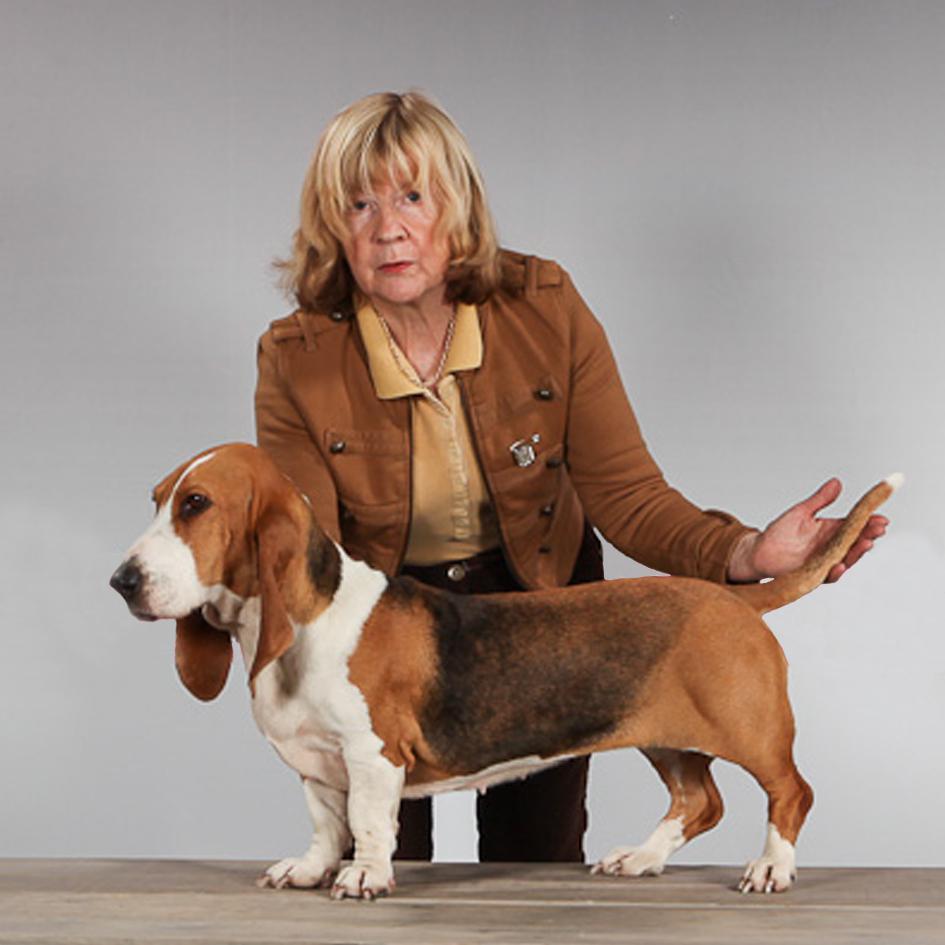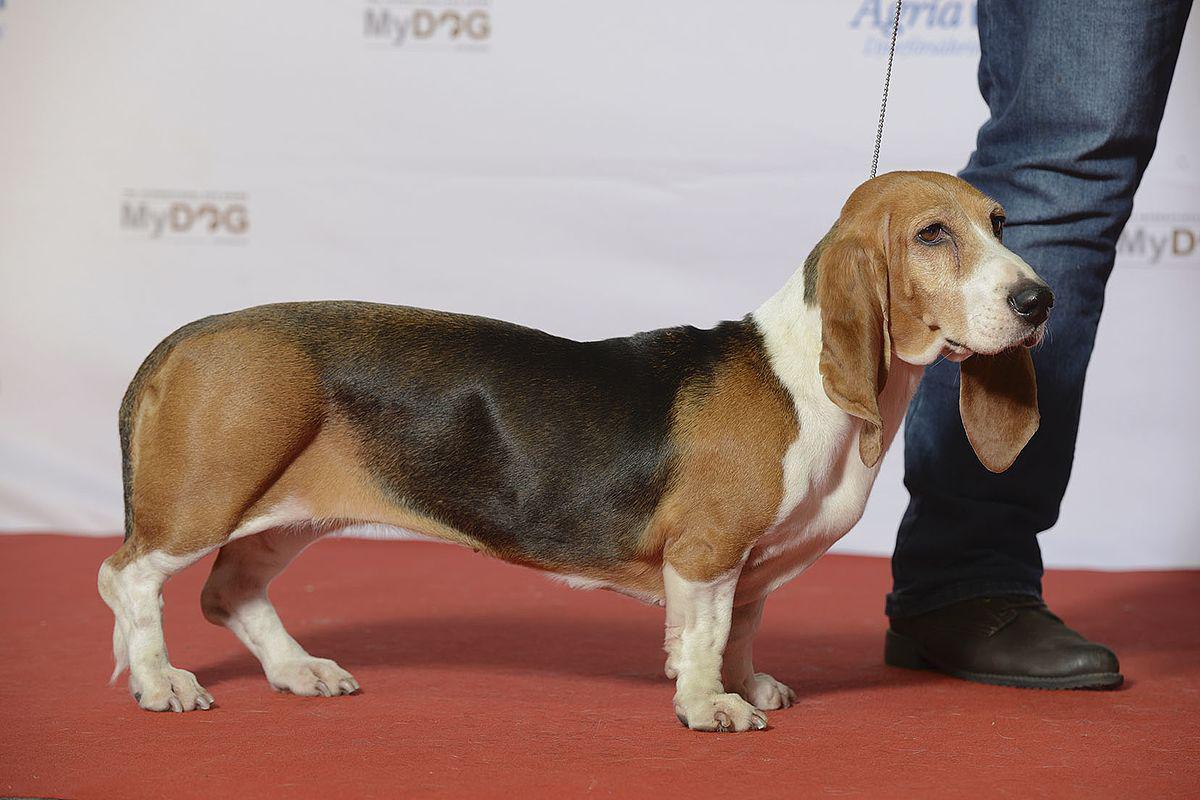The first image is the image on the left, the second image is the image on the right. Given the left and right images, does the statement "Each image shows one standing basset hound, and one image includes a person with hands at the front and back of the dog." hold true? Answer yes or no. Yes. The first image is the image on the left, the second image is the image on the right. Assess this claim about the two images: "there is a beagle outside on the grass". Correct or not? Answer yes or no. No. 